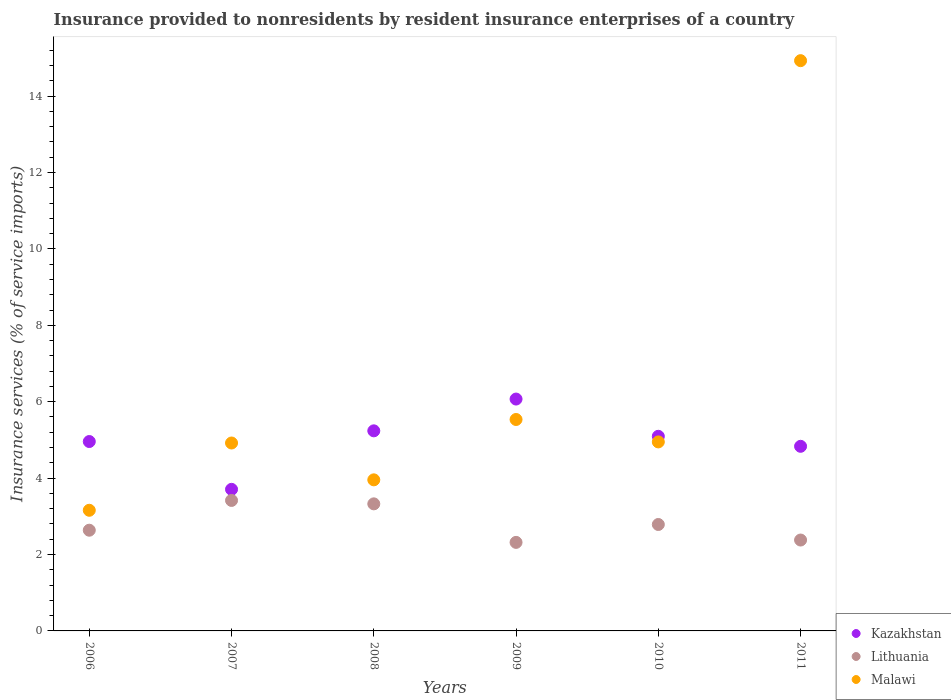How many different coloured dotlines are there?
Your response must be concise. 3. What is the insurance provided to nonresidents in Malawi in 2010?
Your answer should be compact. 4.95. Across all years, what is the maximum insurance provided to nonresidents in Kazakhstan?
Keep it short and to the point. 6.07. Across all years, what is the minimum insurance provided to nonresidents in Kazakhstan?
Offer a very short reply. 3.71. In which year was the insurance provided to nonresidents in Kazakhstan maximum?
Make the answer very short. 2009. In which year was the insurance provided to nonresidents in Lithuania minimum?
Offer a very short reply. 2009. What is the total insurance provided to nonresidents in Kazakhstan in the graph?
Give a very brief answer. 29.9. What is the difference between the insurance provided to nonresidents in Kazakhstan in 2006 and that in 2008?
Make the answer very short. -0.28. What is the difference between the insurance provided to nonresidents in Kazakhstan in 2011 and the insurance provided to nonresidents in Lithuania in 2010?
Offer a very short reply. 2.05. What is the average insurance provided to nonresidents in Lithuania per year?
Offer a very short reply. 2.81. In the year 2010, what is the difference between the insurance provided to nonresidents in Lithuania and insurance provided to nonresidents in Malawi?
Give a very brief answer. -2.16. In how many years, is the insurance provided to nonresidents in Malawi greater than 4.8 %?
Give a very brief answer. 4. What is the ratio of the insurance provided to nonresidents in Kazakhstan in 2007 to that in 2009?
Your response must be concise. 0.61. Is the insurance provided to nonresidents in Lithuania in 2006 less than that in 2010?
Give a very brief answer. Yes. What is the difference between the highest and the second highest insurance provided to nonresidents in Kazakhstan?
Keep it short and to the point. 0.83. What is the difference between the highest and the lowest insurance provided to nonresidents in Kazakhstan?
Offer a very short reply. 2.36. In how many years, is the insurance provided to nonresidents in Kazakhstan greater than the average insurance provided to nonresidents in Kazakhstan taken over all years?
Provide a short and direct response. 3. Is the sum of the insurance provided to nonresidents in Lithuania in 2006 and 2008 greater than the maximum insurance provided to nonresidents in Malawi across all years?
Give a very brief answer. No. Does the insurance provided to nonresidents in Kazakhstan monotonically increase over the years?
Give a very brief answer. No. Are the values on the major ticks of Y-axis written in scientific E-notation?
Offer a terse response. No. Does the graph contain any zero values?
Offer a terse response. No. Does the graph contain grids?
Your response must be concise. No. How many legend labels are there?
Your response must be concise. 3. How are the legend labels stacked?
Provide a short and direct response. Vertical. What is the title of the graph?
Your answer should be compact. Insurance provided to nonresidents by resident insurance enterprises of a country. Does "Kyrgyz Republic" appear as one of the legend labels in the graph?
Your response must be concise. No. What is the label or title of the Y-axis?
Your answer should be very brief. Insurance services (% of service imports). What is the Insurance services (% of service imports) of Kazakhstan in 2006?
Provide a short and direct response. 4.96. What is the Insurance services (% of service imports) in Lithuania in 2006?
Your answer should be very brief. 2.64. What is the Insurance services (% of service imports) of Malawi in 2006?
Ensure brevity in your answer.  3.16. What is the Insurance services (% of service imports) in Kazakhstan in 2007?
Offer a very short reply. 3.71. What is the Insurance services (% of service imports) in Lithuania in 2007?
Ensure brevity in your answer.  3.42. What is the Insurance services (% of service imports) in Malawi in 2007?
Keep it short and to the point. 4.92. What is the Insurance services (% of service imports) of Kazakhstan in 2008?
Keep it short and to the point. 5.24. What is the Insurance services (% of service imports) of Lithuania in 2008?
Your answer should be compact. 3.33. What is the Insurance services (% of service imports) of Malawi in 2008?
Give a very brief answer. 3.95. What is the Insurance services (% of service imports) of Kazakhstan in 2009?
Offer a terse response. 6.07. What is the Insurance services (% of service imports) of Lithuania in 2009?
Provide a short and direct response. 2.32. What is the Insurance services (% of service imports) in Malawi in 2009?
Offer a terse response. 5.53. What is the Insurance services (% of service imports) in Kazakhstan in 2010?
Keep it short and to the point. 5.09. What is the Insurance services (% of service imports) of Lithuania in 2010?
Offer a very short reply. 2.79. What is the Insurance services (% of service imports) in Malawi in 2010?
Your response must be concise. 4.95. What is the Insurance services (% of service imports) of Kazakhstan in 2011?
Give a very brief answer. 4.83. What is the Insurance services (% of service imports) in Lithuania in 2011?
Your response must be concise. 2.38. What is the Insurance services (% of service imports) in Malawi in 2011?
Keep it short and to the point. 14.93. Across all years, what is the maximum Insurance services (% of service imports) in Kazakhstan?
Make the answer very short. 6.07. Across all years, what is the maximum Insurance services (% of service imports) in Lithuania?
Provide a succinct answer. 3.42. Across all years, what is the maximum Insurance services (% of service imports) of Malawi?
Make the answer very short. 14.93. Across all years, what is the minimum Insurance services (% of service imports) of Kazakhstan?
Make the answer very short. 3.71. Across all years, what is the minimum Insurance services (% of service imports) of Lithuania?
Ensure brevity in your answer.  2.32. Across all years, what is the minimum Insurance services (% of service imports) in Malawi?
Provide a succinct answer. 3.16. What is the total Insurance services (% of service imports) of Kazakhstan in the graph?
Ensure brevity in your answer.  29.9. What is the total Insurance services (% of service imports) in Lithuania in the graph?
Your response must be concise. 16.86. What is the total Insurance services (% of service imports) of Malawi in the graph?
Your response must be concise. 37.44. What is the difference between the Insurance services (% of service imports) in Kazakhstan in 2006 and that in 2007?
Your answer should be compact. 1.25. What is the difference between the Insurance services (% of service imports) in Lithuania in 2006 and that in 2007?
Provide a succinct answer. -0.78. What is the difference between the Insurance services (% of service imports) of Malawi in 2006 and that in 2007?
Your answer should be very brief. -1.76. What is the difference between the Insurance services (% of service imports) in Kazakhstan in 2006 and that in 2008?
Provide a succinct answer. -0.28. What is the difference between the Insurance services (% of service imports) of Lithuania in 2006 and that in 2008?
Your answer should be very brief. -0.69. What is the difference between the Insurance services (% of service imports) in Malawi in 2006 and that in 2008?
Your response must be concise. -0.8. What is the difference between the Insurance services (% of service imports) of Kazakhstan in 2006 and that in 2009?
Provide a short and direct response. -1.11. What is the difference between the Insurance services (% of service imports) of Lithuania in 2006 and that in 2009?
Make the answer very short. 0.32. What is the difference between the Insurance services (% of service imports) in Malawi in 2006 and that in 2009?
Your answer should be compact. -2.38. What is the difference between the Insurance services (% of service imports) of Kazakhstan in 2006 and that in 2010?
Offer a very short reply. -0.14. What is the difference between the Insurance services (% of service imports) in Lithuania in 2006 and that in 2010?
Your answer should be very brief. -0.15. What is the difference between the Insurance services (% of service imports) of Malawi in 2006 and that in 2010?
Offer a very short reply. -1.79. What is the difference between the Insurance services (% of service imports) in Kazakhstan in 2006 and that in 2011?
Provide a short and direct response. 0.13. What is the difference between the Insurance services (% of service imports) of Lithuania in 2006 and that in 2011?
Keep it short and to the point. 0.26. What is the difference between the Insurance services (% of service imports) in Malawi in 2006 and that in 2011?
Keep it short and to the point. -11.77. What is the difference between the Insurance services (% of service imports) of Kazakhstan in 2007 and that in 2008?
Offer a very short reply. -1.53. What is the difference between the Insurance services (% of service imports) in Lithuania in 2007 and that in 2008?
Your answer should be very brief. 0.09. What is the difference between the Insurance services (% of service imports) of Kazakhstan in 2007 and that in 2009?
Make the answer very short. -2.36. What is the difference between the Insurance services (% of service imports) of Lithuania in 2007 and that in 2009?
Your answer should be very brief. 1.1. What is the difference between the Insurance services (% of service imports) in Malawi in 2007 and that in 2009?
Ensure brevity in your answer.  -0.62. What is the difference between the Insurance services (% of service imports) in Kazakhstan in 2007 and that in 2010?
Your answer should be compact. -1.39. What is the difference between the Insurance services (% of service imports) in Lithuania in 2007 and that in 2010?
Offer a terse response. 0.63. What is the difference between the Insurance services (% of service imports) in Malawi in 2007 and that in 2010?
Your answer should be compact. -0.03. What is the difference between the Insurance services (% of service imports) of Kazakhstan in 2007 and that in 2011?
Your response must be concise. -1.13. What is the difference between the Insurance services (% of service imports) of Lithuania in 2007 and that in 2011?
Your answer should be very brief. 1.04. What is the difference between the Insurance services (% of service imports) of Malawi in 2007 and that in 2011?
Your answer should be very brief. -10.01. What is the difference between the Insurance services (% of service imports) of Kazakhstan in 2008 and that in 2009?
Ensure brevity in your answer.  -0.83. What is the difference between the Insurance services (% of service imports) in Lithuania in 2008 and that in 2009?
Your response must be concise. 1.01. What is the difference between the Insurance services (% of service imports) of Malawi in 2008 and that in 2009?
Keep it short and to the point. -1.58. What is the difference between the Insurance services (% of service imports) of Kazakhstan in 2008 and that in 2010?
Your answer should be very brief. 0.14. What is the difference between the Insurance services (% of service imports) in Lithuania in 2008 and that in 2010?
Provide a succinct answer. 0.54. What is the difference between the Insurance services (% of service imports) of Malawi in 2008 and that in 2010?
Your answer should be very brief. -0.99. What is the difference between the Insurance services (% of service imports) in Kazakhstan in 2008 and that in 2011?
Provide a short and direct response. 0.41. What is the difference between the Insurance services (% of service imports) in Lithuania in 2008 and that in 2011?
Your response must be concise. 0.95. What is the difference between the Insurance services (% of service imports) in Malawi in 2008 and that in 2011?
Your answer should be compact. -10.97. What is the difference between the Insurance services (% of service imports) of Kazakhstan in 2009 and that in 2010?
Provide a succinct answer. 0.97. What is the difference between the Insurance services (% of service imports) of Lithuania in 2009 and that in 2010?
Ensure brevity in your answer.  -0.47. What is the difference between the Insurance services (% of service imports) in Malawi in 2009 and that in 2010?
Ensure brevity in your answer.  0.59. What is the difference between the Insurance services (% of service imports) of Kazakhstan in 2009 and that in 2011?
Ensure brevity in your answer.  1.24. What is the difference between the Insurance services (% of service imports) of Lithuania in 2009 and that in 2011?
Provide a succinct answer. -0.06. What is the difference between the Insurance services (% of service imports) in Malawi in 2009 and that in 2011?
Give a very brief answer. -9.39. What is the difference between the Insurance services (% of service imports) in Kazakhstan in 2010 and that in 2011?
Your answer should be compact. 0.26. What is the difference between the Insurance services (% of service imports) in Lithuania in 2010 and that in 2011?
Your answer should be very brief. 0.41. What is the difference between the Insurance services (% of service imports) in Malawi in 2010 and that in 2011?
Give a very brief answer. -9.98. What is the difference between the Insurance services (% of service imports) of Kazakhstan in 2006 and the Insurance services (% of service imports) of Lithuania in 2007?
Your response must be concise. 1.54. What is the difference between the Insurance services (% of service imports) in Kazakhstan in 2006 and the Insurance services (% of service imports) in Malawi in 2007?
Offer a terse response. 0.04. What is the difference between the Insurance services (% of service imports) in Lithuania in 2006 and the Insurance services (% of service imports) in Malawi in 2007?
Provide a succinct answer. -2.28. What is the difference between the Insurance services (% of service imports) of Kazakhstan in 2006 and the Insurance services (% of service imports) of Lithuania in 2008?
Provide a succinct answer. 1.63. What is the difference between the Insurance services (% of service imports) of Lithuania in 2006 and the Insurance services (% of service imports) of Malawi in 2008?
Offer a terse response. -1.32. What is the difference between the Insurance services (% of service imports) in Kazakhstan in 2006 and the Insurance services (% of service imports) in Lithuania in 2009?
Offer a terse response. 2.64. What is the difference between the Insurance services (% of service imports) in Kazakhstan in 2006 and the Insurance services (% of service imports) in Malawi in 2009?
Keep it short and to the point. -0.58. What is the difference between the Insurance services (% of service imports) of Lithuania in 2006 and the Insurance services (% of service imports) of Malawi in 2009?
Provide a succinct answer. -2.9. What is the difference between the Insurance services (% of service imports) of Kazakhstan in 2006 and the Insurance services (% of service imports) of Lithuania in 2010?
Provide a succinct answer. 2.17. What is the difference between the Insurance services (% of service imports) in Kazakhstan in 2006 and the Insurance services (% of service imports) in Malawi in 2010?
Offer a very short reply. 0.01. What is the difference between the Insurance services (% of service imports) of Lithuania in 2006 and the Insurance services (% of service imports) of Malawi in 2010?
Keep it short and to the point. -2.31. What is the difference between the Insurance services (% of service imports) in Kazakhstan in 2006 and the Insurance services (% of service imports) in Lithuania in 2011?
Offer a terse response. 2.58. What is the difference between the Insurance services (% of service imports) of Kazakhstan in 2006 and the Insurance services (% of service imports) of Malawi in 2011?
Your answer should be very brief. -9.97. What is the difference between the Insurance services (% of service imports) in Lithuania in 2006 and the Insurance services (% of service imports) in Malawi in 2011?
Provide a succinct answer. -12.29. What is the difference between the Insurance services (% of service imports) in Kazakhstan in 2007 and the Insurance services (% of service imports) in Lithuania in 2008?
Offer a very short reply. 0.38. What is the difference between the Insurance services (% of service imports) of Kazakhstan in 2007 and the Insurance services (% of service imports) of Malawi in 2008?
Your answer should be very brief. -0.25. What is the difference between the Insurance services (% of service imports) of Lithuania in 2007 and the Insurance services (% of service imports) of Malawi in 2008?
Ensure brevity in your answer.  -0.54. What is the difference between the Insurance services (% of service imports) of Kazakhstan in 2007 and the Insurance services (% of service imports) of Lithuania in 2009?
Provide a succinct answer. 1.39. What is the difference between the Insurance services (% of service imports) in Kazakhstan in 2007 and the Insurance services (% of service imports) in Malawi in 2009?
Your answer should be compact. -1.83. What is the difference between the Insurance services (% of service imports) of Lithuania in 2007 and the Insurance services (% of service imports) of Malawi in 2009?
Provide a succinct answer. -2.12. What is the difference between the Insurance services (% of service imports) of Kazakhstan in 2007 and the Insurance services (% of service imports) of Lithuania in 2010?
Your answer should be compact. 0.92. What is the difference between the Insurance services (% of service imports) in Kazakhstan in 2007 and the Insurance services (% of service imports) in Malawi in 2010?
Your answer should be compact. -1.24. What is the difference between the Insurance services (% of service imports) of Lithuania in 2007 and the Insurance services (% of service imports) of Malawi in 2010?
Give a very brief answer. -1.53. What is the difference between the Insurance services (% of service imports) in Kazakhstan in 2007 and the Insurance services (% of service imports) in Lithuania in 2011?
Offer a very short reply. 1.33. What is the difference between the Insurance services (% of service imports) in Kazakhstan in 2007 and the Insurance services (% of service imports) in Malawi in 2011?
Your answer should be compact. -11.22. What is the difference between the Insurance services (% of service imports) of Lithuania in 2007 and the Insurance services (% of service imports) of Malawi in 2011?
Keep it short and to the point. -11.51. What is the difference between the Insurance services (% of service imports) in Kazakhstan in 2008 and the Insurance services (% of service imports) in Lithuania in 2009?
Ensure brevity in your answer.  2.92. What is the difference between the Insurance services (% of service imports) of Kazakhstan in 2008 and the Insurance services (% of service imports) of Malawi in 2009?
Make the answer very short. -0.3. What is the difference between the Insurance services (% of service imports) of Lithuania in 2008 and the Insurance services (% of service imports) of Malawi in 2009?
Your answer should be very brief. -2.21. What is the difference between the Insurance services (% of service imports) of Kazakhstan in 2008 and the Insurance services (% of service imports) of Lithuania in 2010?
Offer a very short reply. 2.45. What is the difference between the Insurance services (% of service imports) in Kazakhstan in 2008 and the Insurance services (% of service imports) in Malawi in 2010?
Make the answer very short. 0.29. What is the difference between the Insurance services (% of service imports) in Lithuania in 2008 and the Insurance services (% of service imports) in Malawi in 2010?
Your answer should be very brief. -1.62. What is the difference between the Insurance services (% of service imports) of Kazakhstan in 2008 and the Insurance services (% of service imports) of Lithuania in 2011?
Your answer should be very brief. 2.86. What is the difference between the Insurance services (% of service imports) in Kazakhstan in 2008 and the Insurance services (% of service imports) in Malawi in 2011?
Make the answer very short. -9.69. What is the difference between the Insurance services (% of service imports) of Lithuania in 2008 and the Insurance services (% of service imports) of Malawi in 2011?
Make the answer very short. -11.6. What is the difference between the Insurance services (% of service imports) in Kazakhstan in 2009 and the Insurance services (% of service imports) in Lithuania in 2010?
Make the answer very short. 3.28. What is the difference between the Insurance services (% of service imports) in Kazakhstan in 2009 and the Insurance services (% of service imports) in Malawi in 2010?
Provide a succinct answer. 1.12. What is the difference between the Insurance services (% of service imports) in Lithuania in 2009 and the Insurance services (% of service imports) in Malawi in 2010?
Give a very brief answer. -2.63. What is the difference between the Insurance services (% of service imports) in Kazakhstan in 2009 and the Insurance services (% of service imports) in Lithuania in 2011?
Provide a succinct answer. 3.69. What is the difference between the Insurance services (% of service imports) of Kazakhstan in 2009 and the Insurance services (% of service imports) of Malawi in 2011?
Give a very brief answer. -8.86. What is the difference between the Insurance services (% of service imports) in Lithuania in 2009 and the Insurance services (% of service imports) in Malawi in 2011?
Provide a succinct answer. -12.61. What is the difference between the Insurance services (% of service imports) of Kazakhstan in 2010 and the Insurance services (% of service imports) of Lithuania in 2011?
Your answer should be very brief. 2.72. What is the difference between the Insurance services (% of service imports) in Kazakhstan in 2010 and the Insurance services (% of service imports) in Malawi in 2011?
Offer a terse response. -9.83. What is the difference between the Insurance services (% of service imports) in Lithuania in 2010 and the Insurance services (% of service imports) in Malawi in 2011?
Your answer should be compact. -12.14. What is the average Insurance services (% of service imports) in Kazakhstan per year?
Keep it short and to the point. 4.98. What is the average Insurance services (% of service imports) in Lithuania per year?
Provide a short and direct response. 2.81. What is the average Insurance services (% of service imports) of Malawi per year?
Provide a short and direct response. 6.24. In the year 2006, what is the difference between the Insurance services (% of service imports) of Kazakhstan and Insurance services (% of service imports) of Lithuania?
Offer a terse response. 2.32. In the year 2006, what is the difference between the Insurance services (% of service imports) of Kazakhstan and Insurance services (% of service imports) of Malawi?
Offer a very short reply. 1.8. In the year 2006, what is the difference between the Insurance services (% of service imports) of Lithuania and Insurance services (% of service imports) of Malawi?
Provide a short and direct response. -0.52. In the year 2007, what is the difference between the Insurance services (% of service imports) of Kazakhstan and Insurance services (% of service imports) of Lithuania?
Offer a terse response. 0.29. In the year 2007, what is the difference between the Insurance services (% of service imports) in Kazakhstan and Insurance services (% of service imports) in Malawi?
Offer a very short reply. -1.21. In the year 2007, what is the difference between the Insurance services (% of service imports) in Lithuania and Insurance services (% of service imports) in Malawi?
Your answer should be very brief. -1.5. In the year 2008, what is the difference between the Insurance services (% of service imports) of Kazakhstan and Insurance services (% of service imports) of Lithuania?
Your answer should be compact. 1.91. In the year 2008, what is the difference between the Insurance services (% of service imports) of Kazakhstan and Insurance services (% of service imports) of Malawi?
Ensure brevity in your answer.  1.28. In the year 2008, what is the difference between the Insurance services (% of service imports) of Lithuania and Insurance services (% of service imports) of Malawi?
Provide a succinct answer. -0.63. In the year 2009, what is the difference between the Insurance services (% of service imports) in Kazakhstan and Insurance services (% of service imports) in Lithuania?
Your answer should be compact. 3.75. In the year 2009, what is the difference between the Insurance services (% of service imports) in Kazakhstan and Insurance services (% of service imports) in Malawi?
Your answer should be compact. 0.53. In the year 2009, what is the difference between the Insurance services (% of service imports) of Lithuania and Insurance services (% of service imports) of Malawi?
Keep it short and to the point. -3.22. In the year 2010, what is the difference between the Insurance services (% of service imports) in Kazakhstan and Insurance services (% of service imports) in Lithuania?
Give a very brief answer. 2.31. In the year 2010, what is the difference between the Insurance services (% of service imports) of Kazakhstan and Insurance services (% of service imports) of Malawi?
Your response must be concise. 0.15. In the year 2010, what is the difference between the Insurance services (% of service imports) in Lithuania and Insurance services (% of service imports) in Malawi?
Your answer should be compact. -2.16. In the year 2011, what is the difference between the Insurance services (% of service imports) in Kazakhstan and Insurance services (% of service imports) in Lithuania?
Your answer should be very brief. 2.45. In the year 2011, what is the difference between the Insurance services (% of service imports) in Kazakhstan and Insurance services (% of service imports) in Malawi?
Provide a short and direct response. -10.09. In the year 2011, what is the difference between the Insurance services (% of service imports) of Lithuania and Insurance services (% of service imports) of Malawi?
Ensure brevity in your answer.  -12.55. What is the ratio of the Insurance services (% of service imports) in Kazakhstan in 2006 to that in 2007?
Provide a short and direct response. 1.34. What is the ratio of the Insurance services (% of service imports) of Lithuania in 2006 to that in 2007?
Give a very brief answer. 0.77. What is the ratio of the Insurance services (% of service imports) in Malawi in 2006 to that in 2007?
Give a very brief answer. 0.64. What is the ratio of the Insurance services (% of service imports) in Kazakhstan in 2006 to that in 2008?
Your answer should be compact. 0.95. What is the ratio of the Insurance services (% of service imports) of Lithuania in 2006 to that in 2008?
Provide a short and direct response. 0.79. What is the ratio of the Insurance services (% of service imports) of Malawi in 2006 to that in 2008?
Offer a terse response. 0.8. What is the ratio of the Insurance services (% of service imports) of Kazakhstan in 2006 to that in 2009?
Your response must be concise. 0.82. What is the ratio of the Insurance services (% of service imports) of Lithuania in 2006 to that in 2009?
Provide a short and direct response. 1.14. What is the ratio of the Insurance services (% of service imports) in Malawi in 2006 to that in 2009?
Offer a terse response. 0.57. What is the ratio of the Insurance services (% of service imports) in Kazakhstan in 2006 to that in 2010?
Give a very brief answer. 0.97. What is the ratio of the Insurance services (% of service imports) in Lithuania in 2006 to that in 2010?
Offer a very short reply. 0.95. What is the ratio of the Insurance services (% of service imports) of Malawi in 2006 to that in 2010?
Your answer should be very brief. 0.64. What is the ratio of the Insurance services (% of service imports) of Kazakhstan in 2006 to that in 2011?
Keep it short and to the point. 1.03. What is the ratio of the Insurance services (% of service imports) of Lithuania in 2006 to that in 2011?
Provide a succinct answer. 1.11. What is the ratio of the Insurance services (% of service imports) in Malawi in 2006 to that in 2011?
Offer a terse response. 0.21. What is the ratio of the Insurance services (% of service imports) of Kazakhstan in 2007 to that in 2008?
Ensure brevity in your answer.  0.71. What is the ratio of the Insurance services (% of service imports) of Lithuania in 2007 to that in 2008?
Your answer should be very brief. 1.03. What is the ratio of the Insurance services (% of service imports) in Malawi in 2007 to that in 2008?
Make the answer very short. 1.24. What is the ratio of the Insurance services (% of service imports) of Kazakhstan in 2007 to that in 2009?
Your answer should be compact. 0.61. What is the ratio of the Insurance services (% of service imports) of Lithuania in 2007 to that in 2009?
Your response must be concise. 1.47. What is the ratio of the Insurance services (% of service imports) of Malawi in 2007 to that in 2009?
Keep it short and to the point. 0.89. What is the ratio of the Insurance services (% of service imports) in Kazakhstan in 2007 to that in 2010?
Offer a very short reply. 0.73. What is the ratio of the Insurance services (% of service imports) of Lithuania in 2007 to that in 2010?
Offer a terse response. 1.23. What is the ratio of the Insurance services (% of service imports) in Malawi in 2007 to that in 2010?
Make the answer very short. 0.99. What is the ratio of the Insurance services (% of service imports) of Kazakhstan in 2007 to that in 2011?
Your answer should be very brief. 0.77. What is the ratio of the Insurance services (% of service imports) of Lithuania in 2007 to that in 2011?
Your answer should be compact. 1.44. What is the ratio of the Insurance services (% of service imports) in Malawi in 2007 to that in 2011?
Offer a very short reply. 0.33. What is the ratio of the Insurance services (% of service imports) of Kazakhstan in 2008 to that in 2009?
Give a very brief answer. 0.86. What is the ratio of the Insurance services (% of service imports) of Lithuania in 2008 to that in 2009?
Provide a succinct answer. 1.44. What is the ratio of the Insurance services (% of service imports) in Malawi in 2008 to that in 2009?
Make the answer very short. 0.71. What is the ratio of the Insurance services (% of service imports) in Kazakhstan in 2008 to that in 2010?
Provide a short and direct response. 1.03. What is the ratio of the Insurance services (% of service imports) in Lithuania in 2008 to that in 2010?
Offer a very short reply. 1.19. What is the ratio of the Insurance services (% of service imports) of Malawi in 2008 to that in 2010?
Your answer should be compact. 0.8. What is the ratio of the Insurance services (% of service imports) of Kazakhstan in 2008 to that in 2011?
Make the answer very short. 1.08. What is the ratio of the Insurance services (% of service imports) in Lithuania in 2008 to that in 2011?
Your response must be concise. 1.4. What is the ratio of the Insurance services (% of service imports) of Malawi in 2008 to that in 2011?
Make the answer very short. 0.26. What is the ratio of the Insurance services (% of service imports) in Kazakhstan in 2009 to that in 2010?
Provide a succinct answer. 1.19. What is the ratio of the Insurance services (% of service imports) in Lithuania in 2009 to that in 2010?
Your answer should be very brief. 0.83. What is the ratio of the Insurance services (% of service imports) in Malawi in 2009 to that in 2010?
Your response must be concise. 1.12. What is the ratio of the Insurance services (% of service imports) in Kazakhstan in 2009 to that in 2011?
Your answer should be compact. 1.26. What is the ratio of the Insurance services (% of service imports) of Lithuania in 2009 to that in 2011?
Give a very brief answer. 0.97. What is the ratio of the Insurance services (% of service imports) of Malawi in 2009 to that in 2011?
Provide a short and direct response. 0.37. What is the ratio of the Insurance services (% of service imports) of Kazakhstan in 2010 to that in 2011?
Make the answer very short. 1.05. What is the ratio of the Insurance services (% of service imports) of Lithuania in 2010 to that in 2011?
Offer a terse response. 1.17. What is the ratio of the Insurance services (% of service imports) of Malawi in 2010 to that in 2011?
Your answer should be compact. 0.33. What is the difference between the highest and the second highest Insurance services (% of service imports) of Kazakhstan?
Offer a terse response. 0.83. What is the difference between the highest and the second highest Insurance services (% of service imports) of Lithuania?
Offer a terse response. 0.09. What is the difference between the highest and the second highest Insurance services (% of service imports) in Malawi?
Your answer should be very brief. 9.39. What is the difference between the highest and the lowest Insurance services (% of service imports) in Kazakhstan?
Offer a terse response. 2.36. What is the difference between the highest and the lowest Insurance services (% of service imports) in Lithuania?
Your answer should be compact. 1.1. What is the difference between the highest and the lowest Insurance services (% of service imports) of Malawi?
Provide a short and direct response. 11.77. 